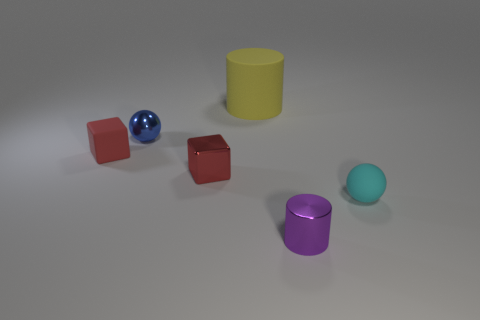Are there fewer big yellow rubber objects that are on the right side of the red metallic cube than small red rubber objects that are behind the yellow cylinder?
Offer a very short reply. No. Is the number of tiny red metallic objects that are behind the purple shiny cylinder less than the number of cyan metallic objects?
Keep it short and to the point. No. There is a small red thing that is on the right side of the small rubber thing that is on the left side of the thing that is to the right of the purple thing; what is it made of?
Keep it short and to the point. Metal. How many objects are objects that are behind the blue ball or objects that are to the left of the big object?
Your answer should be compact. 4. What material is the other small red object that is the same shape as the red matte thing?
Keep it short and to the point. Metal. What number of matte objects are cubes or red spheres?
Your response must be concise. 1. There is a red object that is made of the same material as the small purple cylinder; what is its shape?
Offer a very short reply. Cube. How many red objects have the same shape as the purple object?
Offer a terse response. 0. There is a small rubber thing left of the tiny purple metallic thing; does it have the same shape as the tiny shiny thing that is in front of the red shiny cube?
Offer a terse response. No. What number of things are either small shiny balls or metal objects that are in front of the blue metallic ball?
Keep it short and to the point. 3. 